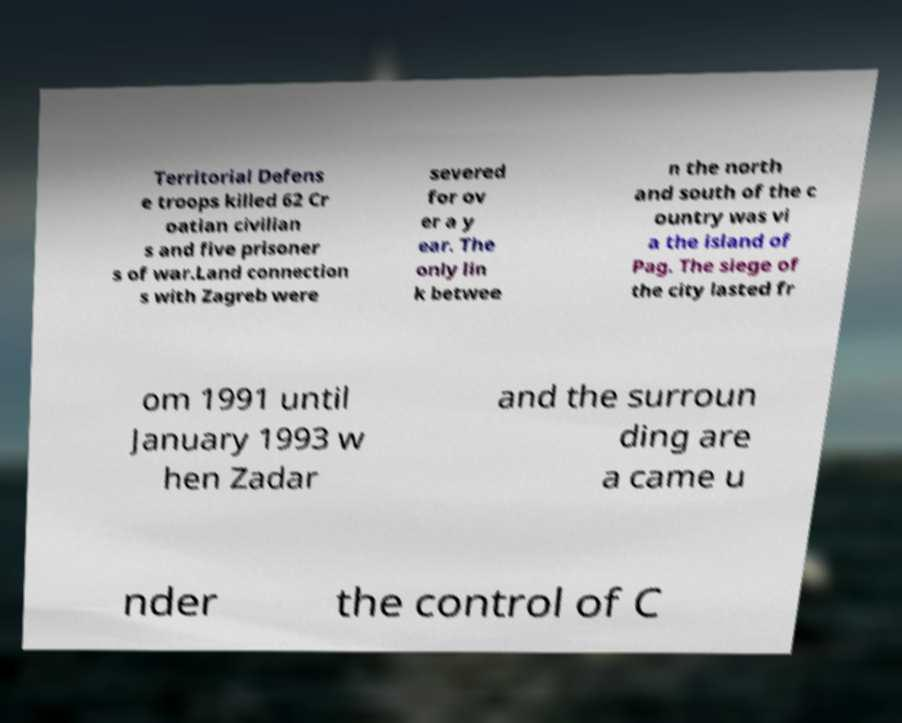I need the written content from this picture converted into text. Can you do that? Territorial Defens e troops killed 62 Cr oatian civilian s and five prisoner s of war.Land connection s with Zagreb were severed for ov er a y ear. The only lin k betwee n the north and south of the c ountry was vi a the island of Pag. The siege of the city lasted fr om 1991 until January 1993 w hen Zadar and the surroun ding are a came u nder the control of C 